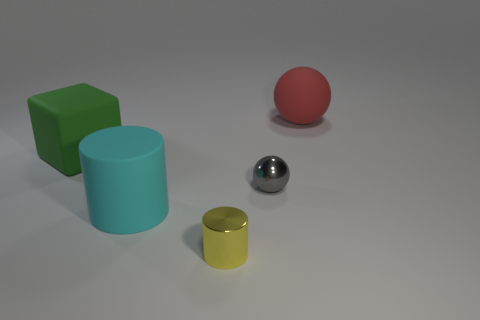Add 1 small green metallic spheres. How many objects exist? 6 Subtract all yellow cylinders. How many cylinders are left? 1 Subtract 1 spheres. How many spheres are left? 1 Subtract all cylinders. How many objects are left? 3 Subtract all cyan cylinders. How many blue blocks are left? 0 Subtract all red cylinders. Subtract all blue blocks. How many cylinders are left? 2 Subtract all green metal things. Subtract all tiny gray metallic things. How many objects are left? 4 Add 5 big red spheres. How many big red spheres are left? 6 Add 2 big cylinders. How many big cylinders exist? 3 Subtract 0 red cubes. How many objects are left? 5 